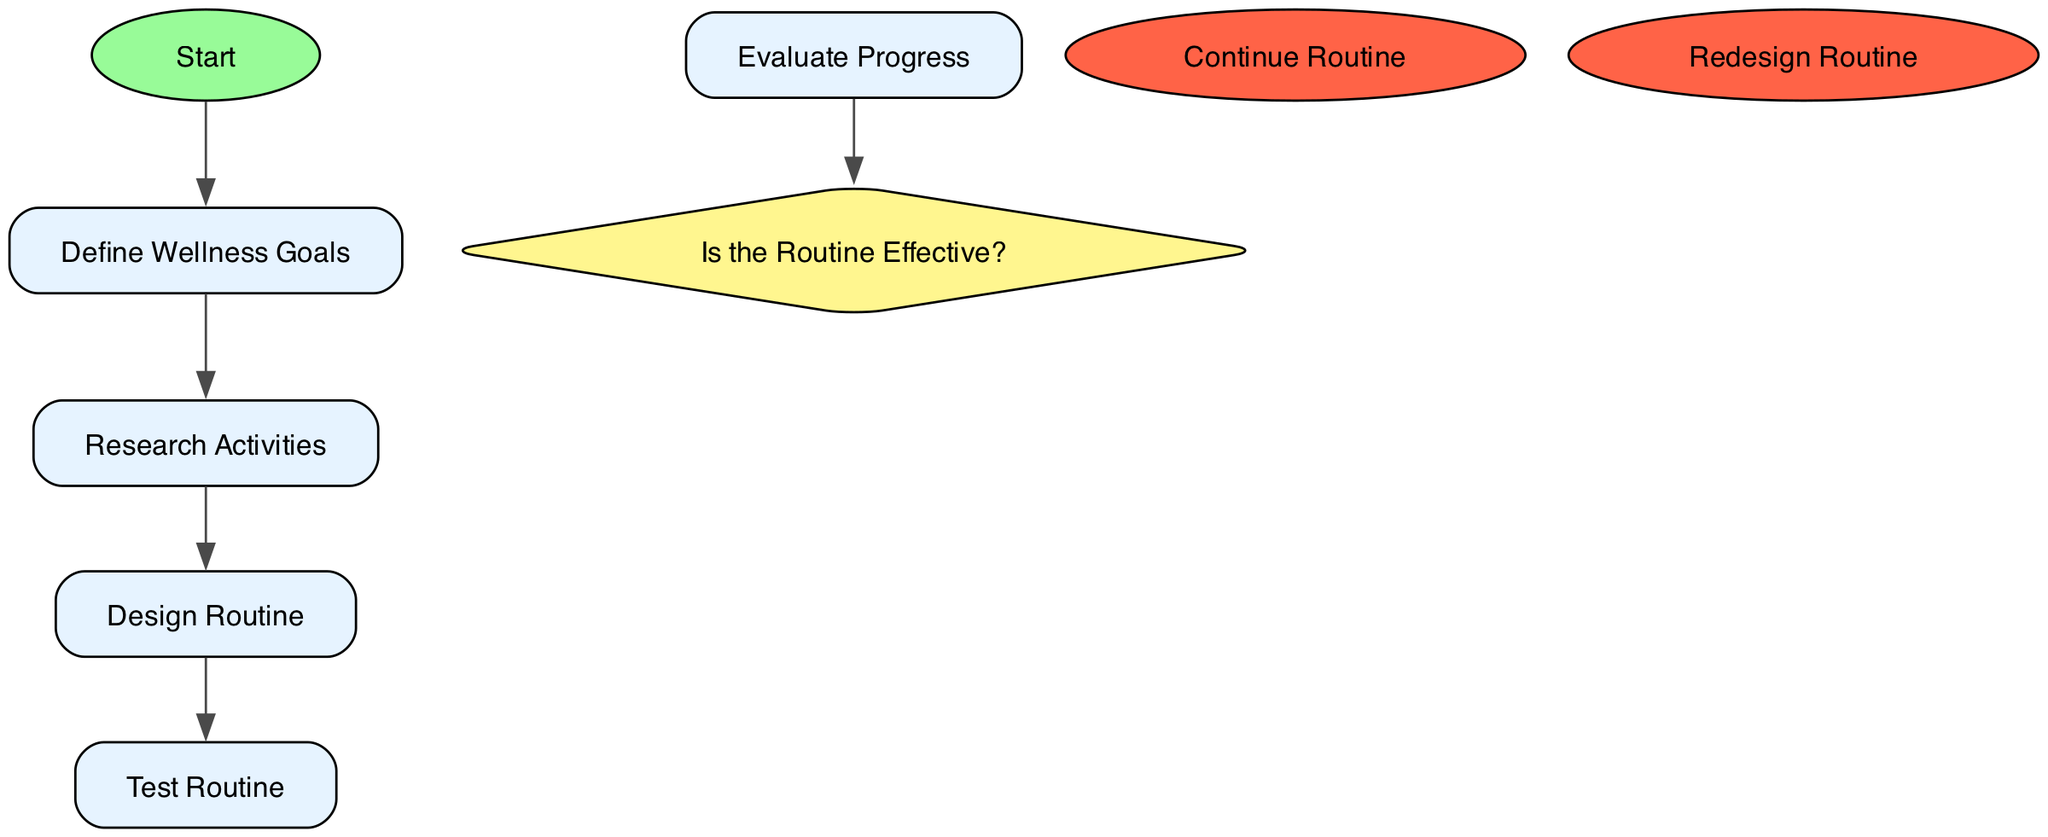What is the first action in the diagram? The first action in the diagram is identified by starting at the 'Start' node and following the first action node sequentially, which is 'Define Wellness Goals'.
Answer: Define Wellness Goals How many action nodes are present in the diagram? To find the number of action nodes, we can count the nodes listed under 'actions' in the data, which totals five.
Answer: 5 What happens if the routine is evaluated as effective? If the routine is evaluated as effective, we follow the flow from the decision node 'Is the Routine Effective?' to the node 'Continue Routine', indicating that the process continues.
Answer: Continue Routine What is the next step after 'Evaluate Progress'? The next step after 'Evaluate Progress' depends on whether the routine is effective; it leads to a decision node where the 'Is the Routine Effective?' question prompts a further action based on the answer.
Answer: Is the Routine Effective? What does the action 'Redesign Routine' signify? The action 'Redesign Routine' signifies that upon evaluating progress, if the routine is not effective, adjustments are necessary, prompting a return to the 'Design Routine' step to create a new plan.
Answer: Routine needs adjustments How many decision nodes are present in the diagram? To determine the number of decision nodes, we examine the elements under 'decisionNodes', which shows there is one decision node named 'Is the Routine Effective?'.
Answer: 1 What is the flow direction starting from 'Define Wellness Goals' to the end? The flow direction moves from 'Define Wellness Goals' to 'Research Activities', then to 'Design Routine', followed by 'Test Routine', and finally 'Evaluate Progress' before reaching the decision node.
Answer: Sequence of actions What does the label 'Yes' indicate in the decision node? The label 'Yes' indicates that if the routine is determined effective during the evaluation, the process flows to the 'Continue Routine' node, suggesting that the user should persist with the current routine.
Answer: Continue Routine What does the node labeled 'Test Routine' represent in the overall process? The node 'Test Routine' represents the stage where the user implements the designed routine and reflects on how it fits into their daily life, allowing for practical evaluation.
Answer: Implement the routine 